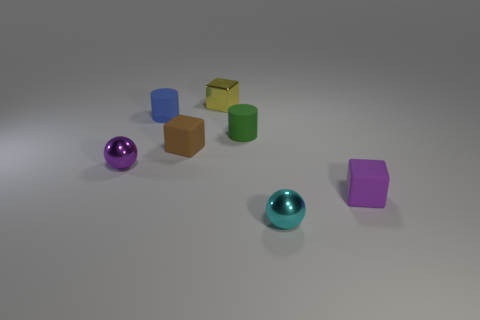Add 3 small rubber blocks. How many objects exist? 10 Subtract all spheres. How many objects are left? 5 Add 4 brown rubber blocks. How many brown rubber blocks are left? 5 Add 1 brown things. How many brown things exist? 2 Subtract 0 yellow cylinders. How many objects are left? 7 Subtract all small green spheres. Subtract all cyan balls. How many objects are left? 6 